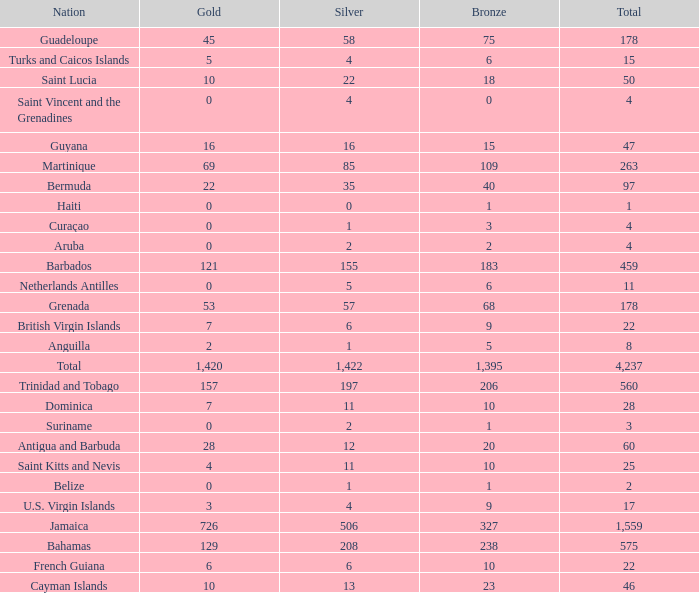What's the total number of Silver that has Gold that's larger than 0, Bronze that's smaller than 23, a Total that's larger than 22, and has the Nation of Saint Kitts and Nevis? 1.0. 